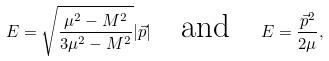<formula> <loc_0><loc_0><loc_500><loc_500>E = \sqrt { \frac { \mu ^ { 2 } - M ^ { 2 } } { 3 \mu ^ { 2 } - M ^ { 2 } } } | \vec { p } | \quad \text {and} \quad E = \frac { \vec { p } ^ { 2 } } { 2 \mu } ,</formula> 